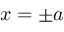<formula> <loc_0><loc_0><loc_500><loc_500>x = \pm a</formula> 